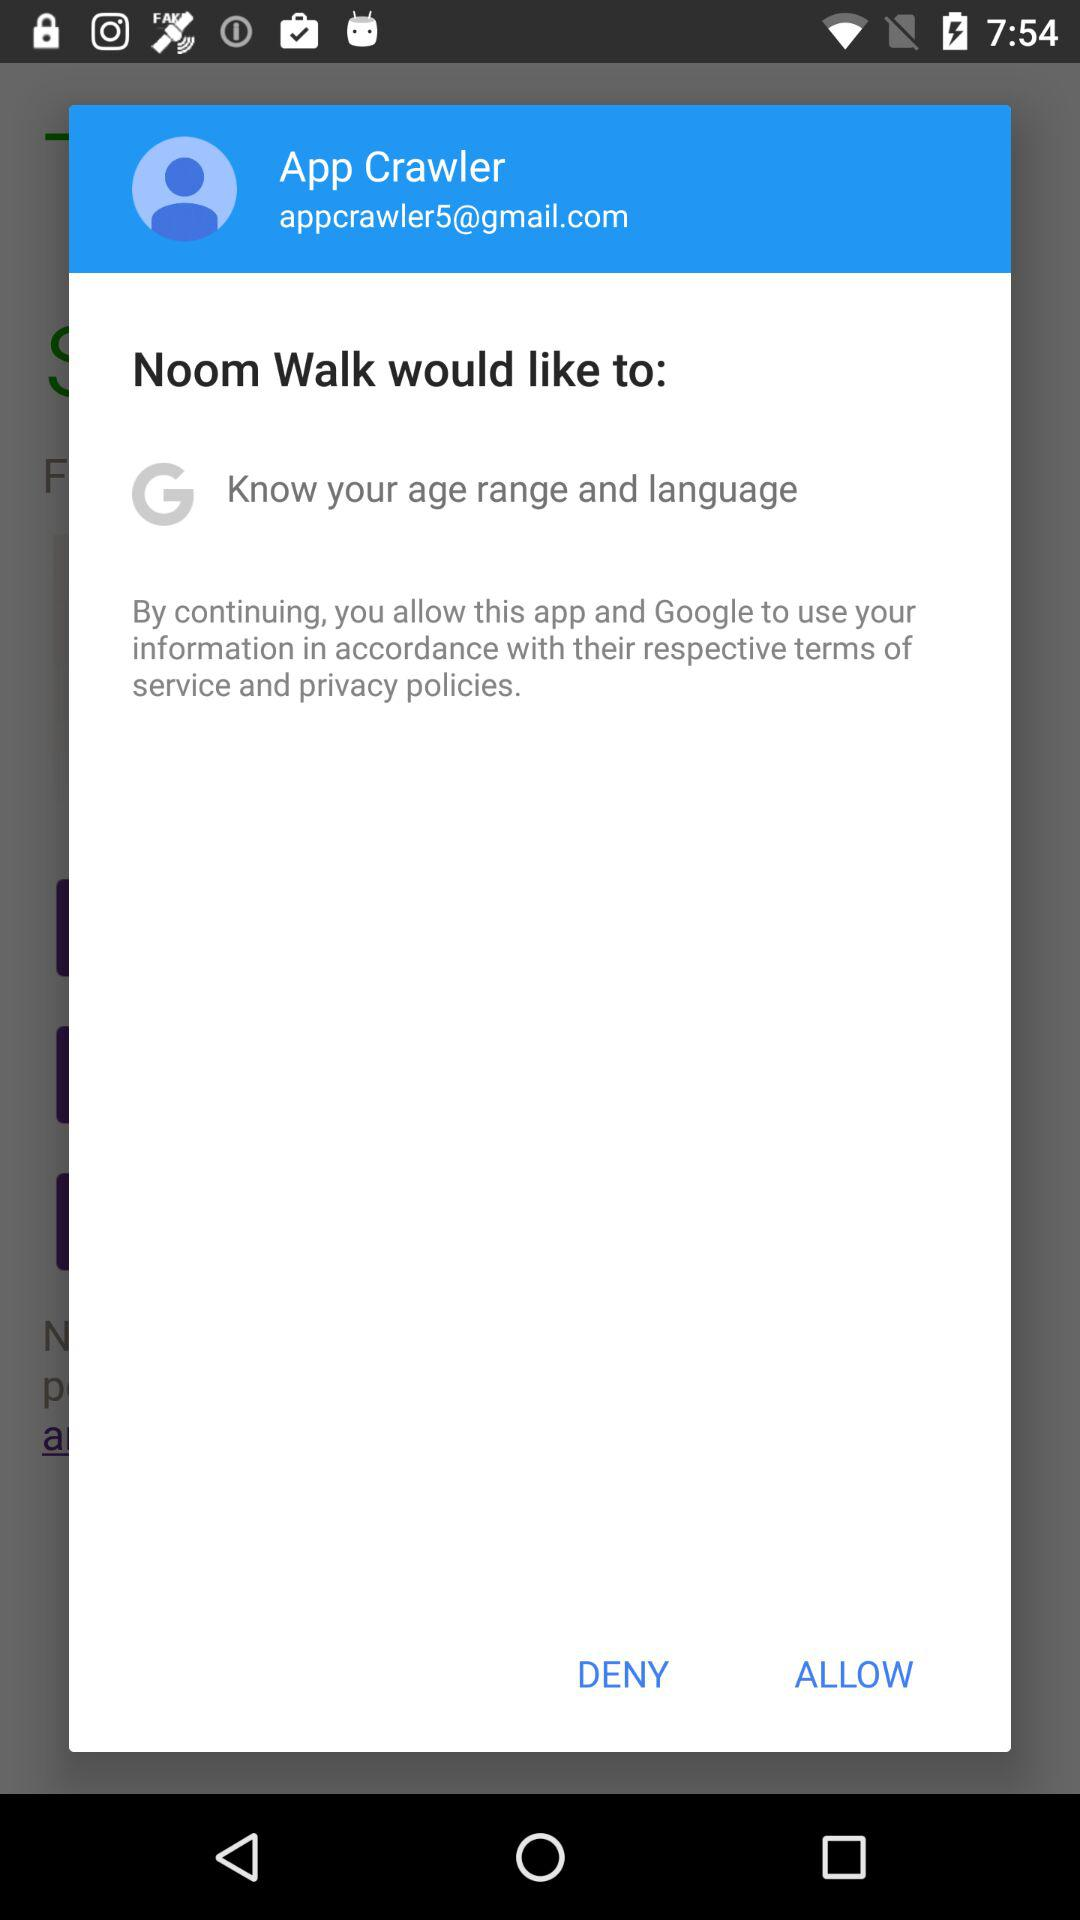What is the email address? The email address is appcrawler5@gmail.com. 